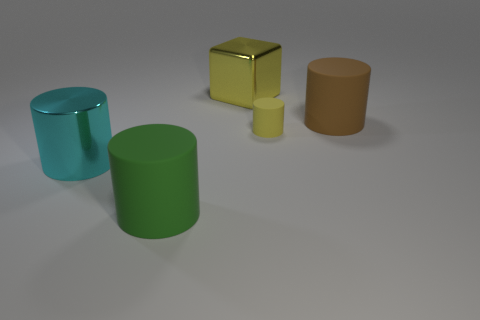Is the size of the brown rubber thing the same as the cyan metal thing?
Provide a short and direct response. Yes. The yellow thing that is the same material as the brown cylinder is what size?
Make the answer very short. Small. What number of small rubber cylinders are the same color as the metallic block?
Offer a terse response. 1. Are there fewer big cyan cylinders behind the large green rubber cylinder than cylinders that are on the left side of the large yellow metal object?
Your response must be concise. Yes. Does the small yellow object behind the big shiny cylinder have the same shape as the big yellow thing?
Your answer should be compact. No. Does the large cylinder that is right of the tiny yellow cylinder have the same material as the big green thing?
Provide a succinct answer. Yes. What is the big brown cylinder behind the matte thing that is in front of the shiny thing in front of the big yellow metal object made of?
Ensure brevity in your answer.  Rubber. What number of other things are the same shape as the tiny yellow rubber object?
Ensure brevity in your answer.  3. What is the color of the thing that is right of the small matte cylinder?
Give a very brief answer. Brown. What number of large yellow cubes are to the left of the large metal object that is left of the big rubber thing in front of the small yellow matte cylinder?
Make the answer very short. 0. 